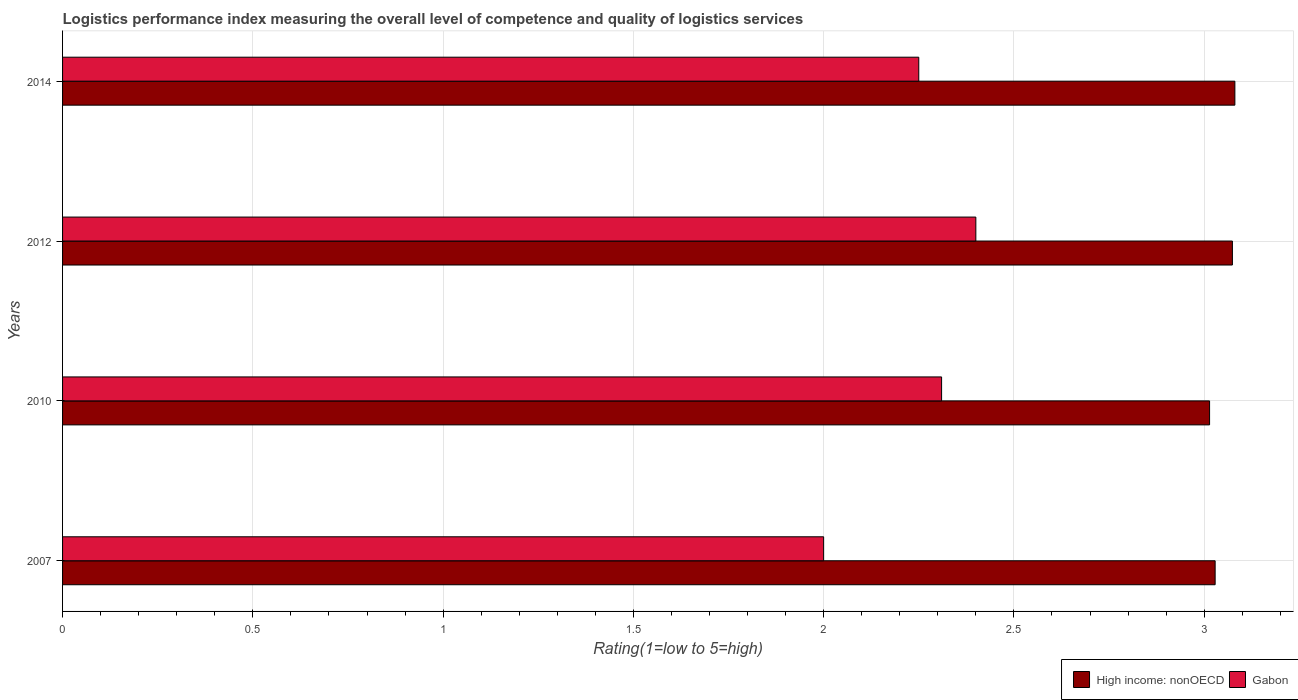Are the number of bars per tick equal to the number of legend labels?
Offer a very short reply. Yes. In how many cases, is the number of bars for a given year not equal to the number of legend labels?
Keep it short and to the point. 0. What is the Logistic performance index in High income: nonOECD in 2014?
Give a very brief answer. 3.08. In which year was the Logistic performance index in High income: nonOECD minimum?
Offer a very short reply. 2010. What is the total Logistic performance index in High income: nonOECD in the graph?
Ensure brevity in your answer.  12.2. What is the difference between the Logistic performance index in High income: nonOECD in 2007 and that in 2010?
Give a very brief answer. 0.01. What is the difference between the Logistic performance index in High income: nonOECD in 2010 and the Logistic performance index in Gabon in 2012?
Offer a very short reply. 0.61. What is the average Logistic performance index in High income: nonOECD per year?
Offer a terse response. 3.05. In the year 2014, what is the difference between the Logistic performance index in High income: nonOECD and Logistic performance index in Gabon?
Give a very brief answer. 0.83. What is the ratio of the Logistic performance index in Gabon in 2007 to that in 2010?
Your answer should be compact. 0.87. What is the difference between the highest and the second highest Logistic performance index in High income: nonOECD?
Provide a short and direct response. 0.01. What is the difference between the highest and the lowest Logistic performance index in Gabon?
Provide a succinct answer. 0.4. In how many years, is the Logistic performance index in Gabon greater than the average Logistic performance index in Gabon taken over all years?
Your answer should be compact. 3. Is the sum of the Logistic performance index in Gabon in 2012 and 2014 greater than the maximum Logistic performance index in High income: nonOECD across all years?
Make the answer very short. Yes. What does the 2nd bar from the top in 2014 represents?
Your response must be concise. High income: nonOECD. What does the 1st bar from the bottom in 2007 represents?
Offer a terse response. High income: nonOECD. Are all the bars in the graph horizontal?
Provide a succinct answer. Yes. How many years are there in the graph?
Make the answer very short. 4. How are the legend labels stacked?
Your answer should be compact. Horizontal. What is the title of the graph?
Your answer should be compact. Logistics performance index measuring the overall level of competence and quality of logistics services. Does "Zimbabwe" appear as one of the legend labels in the graph?
Keep it short and to the point. No. What is the label or title of the X-axis?
Provide a short and direct response. Rating(1=low to 5=high). What is the Rating(1=low to 5=high) of High income: nonOECD in 2007?
Make the answer very short. 3.03. What is the Rating(1=low to 5=high) of Gabon in 2007?
Your answer should be compact. 2. What is the Rating(1=low to 5=high) of High income: nonOECD in 2010?
Your answer should be compact. 3.01. What is the Rating(1=low to 5=high) of Gabon in 2010?
Keep it short and to the point. 2.31. What is the Rating(1=low to 5=high) in High income: nonOECD in 2012?
Make the answer very short. 3.07. What is the Rating(1=low to 5=high) of High income: nonOECD in 2014?
Your answer should be compact. 3.08. What is the Rating(1=low to 5=high) of Gabon in 2014?
Provide a short and direct response. 2.25. Across all years, what is the maximum Rating(1=low to 5=high) in High income: nonOECD?
Offer a terse response. 3.08. Across all years, what is the maximum Rating(1=low to 5=high) in Gabon?
Keep it short and to the point. 2.4. Across all years, what is the minimum Rating(1=low to 5=high) in High income: nonOECD?
Ensure brevity in your answer.  3.01. Across all years, what is the minimum Rating(1=low to 5=high) of Gabon?
Keep it short and to the point. 2. What is the total Rating(1=low to 5=high) in High income: nonOECD in the graph?
Offer a terse response. 12.2. What is the total Rating(1=low to 5=high) in Gabon in the graph?
Ensure brevity in your answer.  8.96. What is the difference between the Rating(1=low to 5=high) in High income: nonOECD in 2007 and that in 2010?
Make the answer very short. 0.01. What is the difference between the Rating(1=low to 5=high) of Gabon in 2007 and that in 2010?
Make the answer very short. -0.31. What is the difference between the Rating(1=low to 5=high) of High income: nonOECD in 2007 and that in 2012?
Provide a succinct answer. -0.05. What is the difference between the Rating(1=low to 5=high) of Gabon in 2007 and that in 2012?
Make the answer very short. -0.4. What is the difference between the Rating(1=low to 5=high) of High income: nonOECD in 2007 and that in 2014?
Provide a succinct answer. -0.05. What is the difference between the Rating(1=low to 5=high) of High income: nonOECD in 2010 and that in 2012?
Offer a terse response. -0.06. What is the difference between the Rating(1=low to 5=high) in Gabon in 2010 and that in 2012?
Keep it short and to the point. -0.09. What is the difference between the Rating(1=low to 5=high) of High income: nonOECD in 2010 and that in 2014?
Keep it short and to the point. -0.07. What is the difference between the Rating(1=low to 5=high) of Gabon in 2010 and that in 2014?
Keep it short and to the point. 0.06. What is the difference between the Rating(1=low to 5=high) of High income: nonOECD in 2012 and that in 2014?
Your response must be concise. -0.01. What is the difference between the Rating(1=low to 5=high) in Gabon in 2012 and that in 2014?
Your response must be concise. 0.15. What is the difference between the Rating(1=low to 5=high) in High income: nonOECD in 2007 and the Rating(1=low to 5=high) in Gabon in 2010?
Your answer should be compact. 0.72. What is the difference between the Rating(1=low to 5=high) of High income: nonOECD in 2007 and the Rating(1=low to 5=high) of Gabon in 2012?
Provide a short and direct response. 0.63. What is the difference between the Rating(1=low to 5=high) of High income: nonOECD in 2007 and the Rating(1=low to 5=high) of Gabon in 2014?
Your answer should be very brief. 0.78. What is the difference between the Rating(1=low to 5=high) of High income: nonOECD in 2010 and the Rating(1=low to 5=high) of Gabon in 2012?
Your answer should be compact. 0.61. What is the difference between the Rating(1=low to 5=high) of High income: nonOECD in 2010 and the Rating(1=low to 5=high) of Gabon in 2014?
Make the answer very short. 0.76. What is the difference between the Rating(1=low to 5=high) of High income: nonOECD in 2012 and the Rating(1=low to 5=high) of Gabon in 2014?
Offer a very short reply. 0.82. What is the average Rating(1=low to 5=high) in High income: nonOECD per year?
Your answer should be very brief. 3.05. What is the average Rating(1=low to 5=high) in Gabon per year?
Your answer should be compact. 2.24. In the year 2007, what is the difference between the Rating(1=low to 5=high) of High income: nonOECD and Rating(1=low to 5=high) of Gabon?
Offer a very short reply. 1.03. In the year 2010, what is the difference between the Rating(1=low to 5=high) of High income: nonOECD and Rating(1=low to 5=high) of Gabon?
Offer a terse response. 0.7. In the year 2012, what is the difference between the Rating(1=low to 5=high) of High income: nonOECD and Rating(1=low to 5=high) of Gabon?
Your answer should be very brief. 0.67. In the year 2014, what is the difference between the Rating(1=low to 5=high) of High income: nonOECD and Rating(1=low to 5=high) of Gabon?
Give a very brief answer. 0.83. What is the ratio of the Rating(1=low to 5=high) in High income: nonOECD in 2007 to that in 2010?
Your answer should be compact. 1. What is the ratio of the Rating(1=low to 5=high) of Gabon in 2007 to that in 2010?
Provide a succinct answer. 0.87. What is the ratio of the Rating(1=low to 5=high) in High income: nonOECD in 2007 to that in 2012?
Make the answer very short. 0.99. What is the ratio of the Rating(1=low to 5=high) of High income: nonOECD in 2007 to that in 2014?
Provide a short and direct response. 0.98. What is the ratio of the Rating(1=low to 5=high) in High income: nonOECD in 2010 to that in 2012?
Give a very brief answer. 0.98. What is the ratio of the Rating(1=low to 5=high) of Gabon in 2010 to that in 2012?
Your response must be concise. 0.96. What is the ratio of the Rating(1=low to 5=high) of High income: nonOECD in 2010 to that in 2014?
Your answer should be very brief. 0.98. What is the ratio of the Rating(1=low to 5=high) of Gabon in 2010 to that in 2014?
Ensure brevity in your answer.  1.03. What is the ratio of the Rating(1=low to 5=high) of Gabon in 2012 to that in 2014?
Your answer should be compact. 1.07. What is the difference between the highest and the second highest Rating(1=low to 5=high) of High income: nonOECD?
Offer a terse response. 0.01. What is the difference between the highest and the second highest Rating(1=low to 5=high) of Gabon?
Your answer should be compact. 0.09. What is the difference between the highest and the lowest Rating(1=low to 5=high) of High income: nonOECD?
Provide a short and direct response. 0.07. What is the difference between the highest and the lowest Rating(1=low to 5=high) in Gabon?
Offer a terse response. 0.4. 